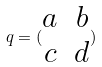Convert formula to latex. <formula><loc_0><loc_0><loc_500><loc_500>q = ( \begin{matrix} a & b \\ c & d \end{matrix} )</formula> 